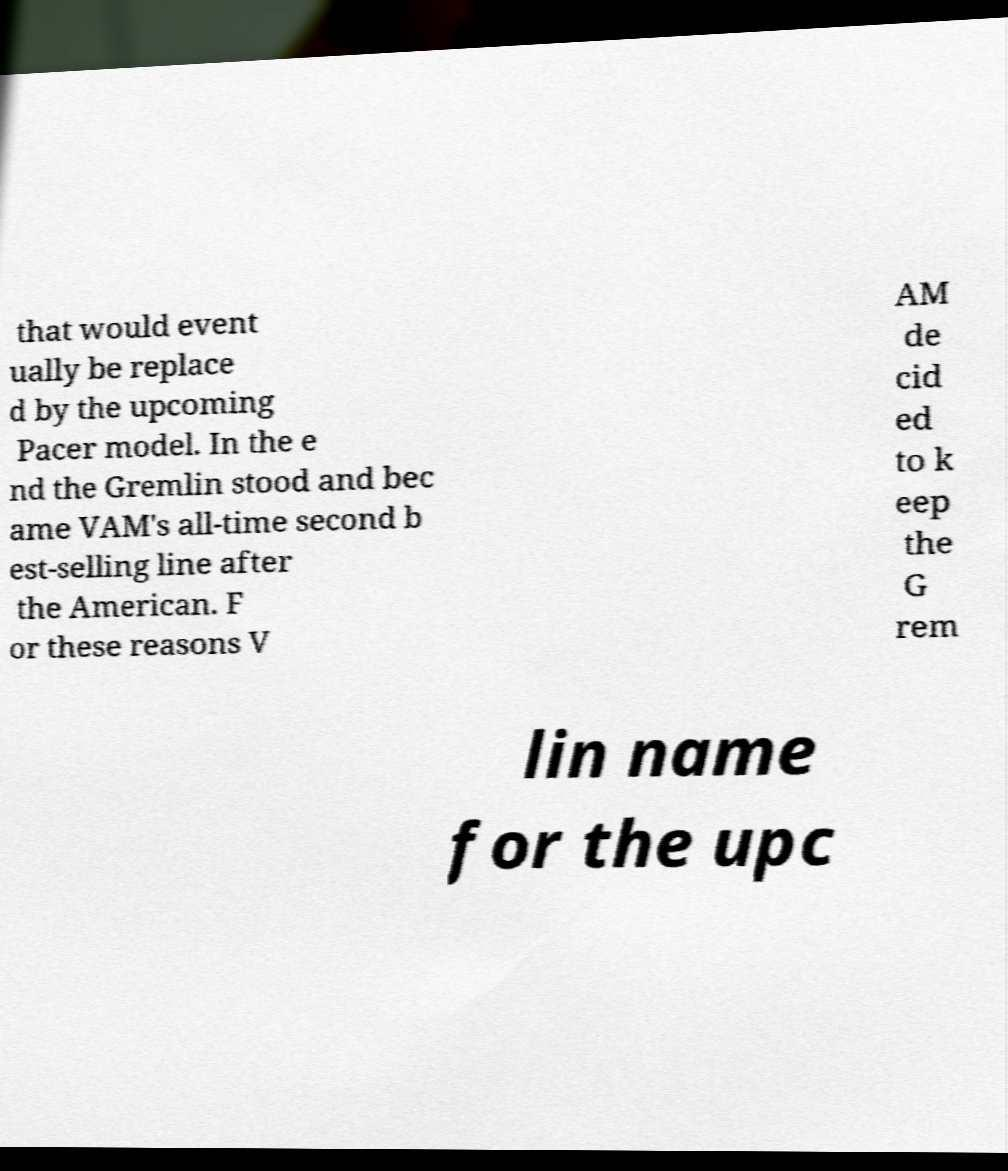For documentation purposes, I need the text within this image transcribed. Could you provide that? that would event ually be replace d by the upcoming Pacer model. In the e nd the Gremlin stood and bec ame VAM's all-time second b est-selling line after the American. F or these reasons V AM de cid ed to k eep the G rem lin name for the upc 